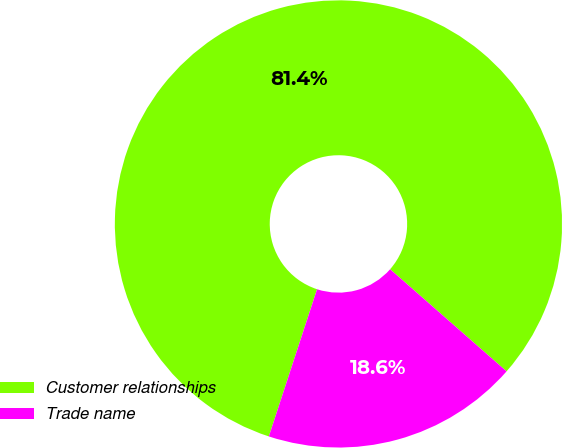<chart> <loc_0><loc_0><loc_500><loc_500><pie_chart><fcel>Customer relationships<fcel>Trade name<nl><fcel>81.42%<fcel>18.58%<nl></chart> 